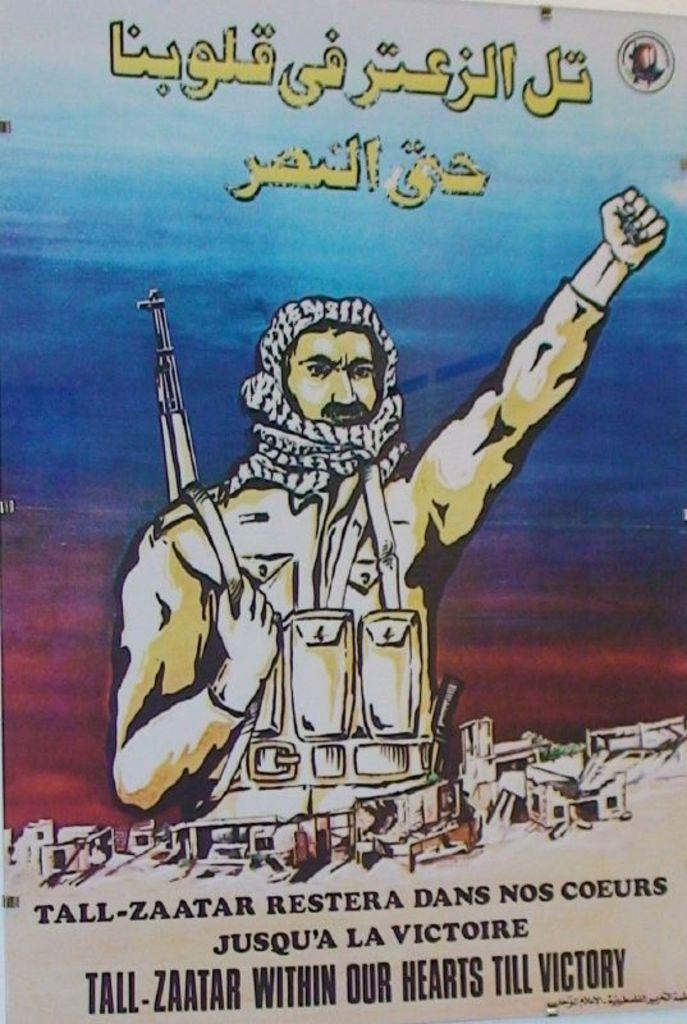Provide a one-sentence caption for the provided image. An illustrated poster shows a soldier with a gun over his shoulder and Tall Zaatar within our hearts till victory at the bottom. 